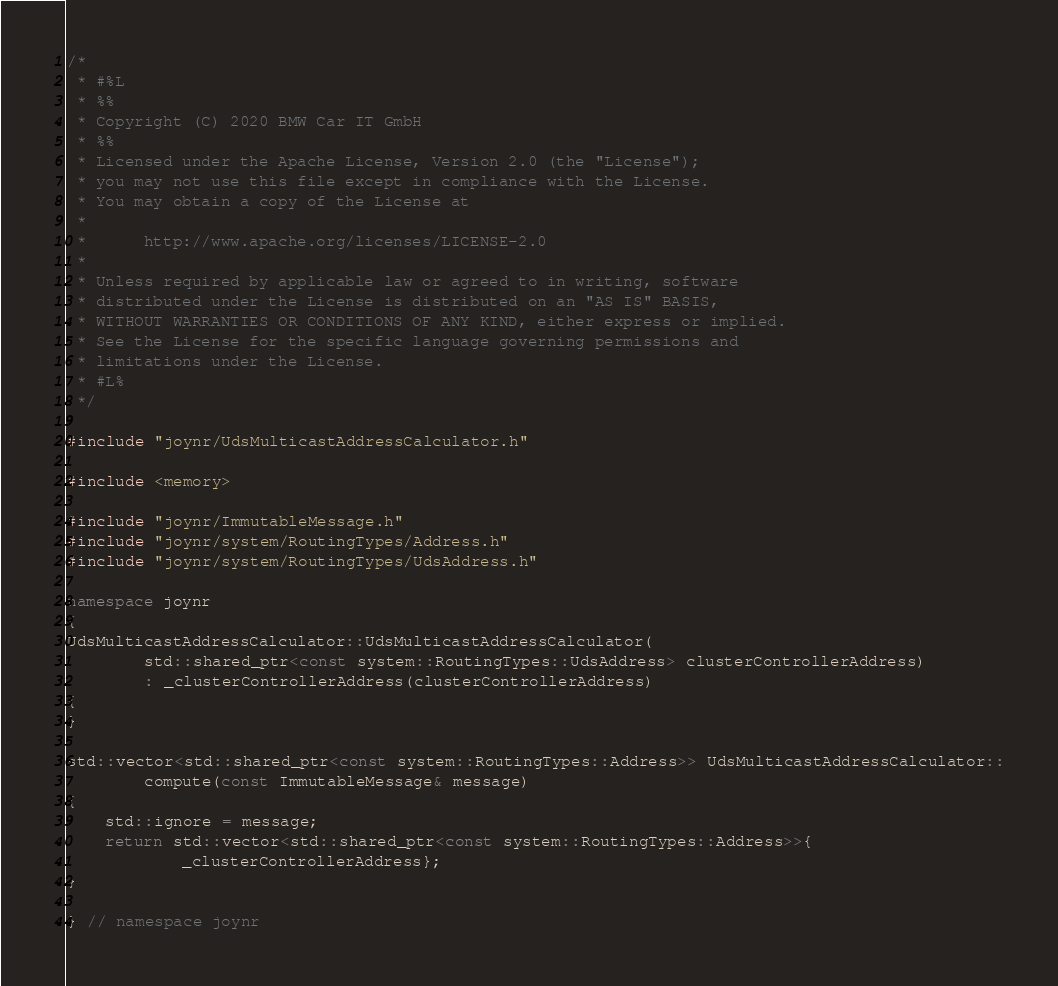<code> <loc_0><loc_0><loc_500><loc_500><_C++_>/*
 * #%L
 * %%
 * Copyright (C) 2020 BMW Car IT GmbH
 * %%
 * Licensed under the Apache License, Version 2.0 (the "License");
 * you may not use this file except in compliance with the License.
 * You may obtain a copy of the License at
 * 
 *      http://www.apache.org/licenses/LICENSE-2.0
 * 
 * Unless required by applicable law or agreed to in writing, software
 * distributed under the License is distributed on an "AS IS" BASIS,
 * WITHOUT WARRANTIES OR CONDITIONS OF ANY KIND, either express or implied.
 * See the License for the specific language governing permissions and
 * limitations under the License.
 * #L%
 */

#include "joynr/UdsMulticastAddressCalculator.h"

#include <memory>

#include "joynr/ImmutableMessage.h"
#include "joynr/system/RoutingTypes/Address.h"
#include "joynr/system/RoutingTypes/UdsAddress.h"

namespace joynr
{
UdsMulticastAddressCalculator::UdsMulticastAddressCalculator(
        std::shared_ptr<const system::RoutingTypes::UdsAddress> clusterControllerAddress)
        : _clusterControllerAddress(clusterControllerAddress)
{
}

std::vector<std::shared_ptr<const system::RoutingTypes::Address>> UdsMulticastAddressCalculator::
        compute(const ImmutableMessage& message)
{
    std::ignore = message;
    return std::vector<std::shared_ptr<const system::RoutingTypes::Address>>{
            _clusterControllerAddress};
}

} // namespace joynr
</code> 